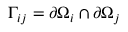Convert formula to latex. <formula><loc_0><loc_0><loc_500><loc_500>\Gamma _ { i j } = \partial \Omega _ { i } \cap \partial \Omega _ { j }</formula> 